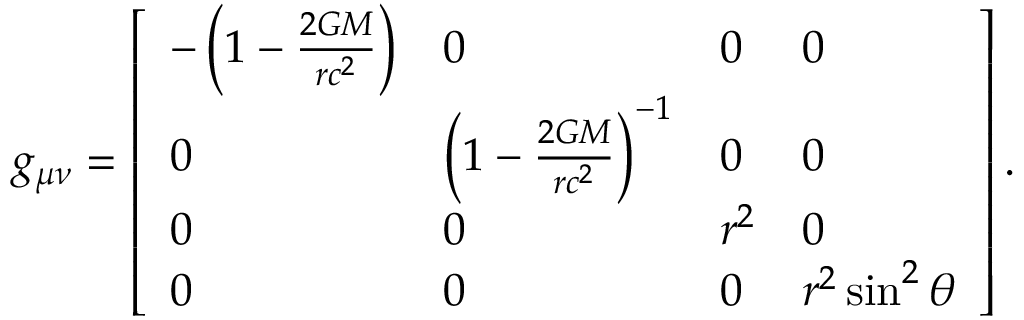<formula> <loc_0><loc_0><loc_500><loc_500>g _ { \mu \nu } = { \left [ \begin{array} { l l l l } { - \left ( 1 - { \frac { 2 G M } { r c ^ { 2 } } } \right ) } & { 0 } & { 0 } & { 0 } \\ { 0 } & { \left ( 1 - { \frac { 2 G M } { r c ^ { 2 } } } \right ) ^ { - 1 } } & { 0 } & { 0 } \\ { 0 } & { 0 } & { r ^ { 2 } } & { 0 } \\ { 0 } & { 0 } & { 0 } & { r ^ { 2 } \sin ^ { 2 } \theta } \end{array} \right ] } \, .</formula> 